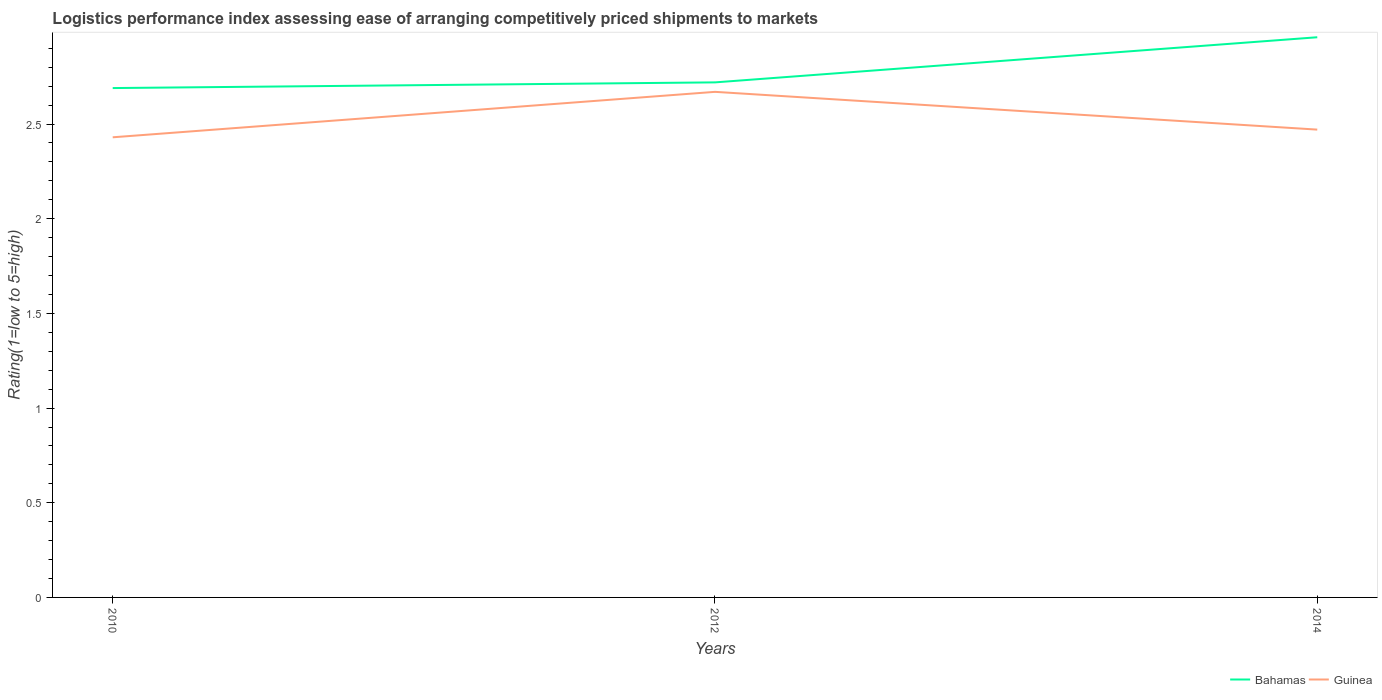How many different coloured lines are there?
Keep it short and to the point. 2. Across all years, what is the maximum Logistic performance index in Guinea?
Keep it short and to the point. 2.43. In which year was the Logistic performance index in Guinea maximum?
Make the answer very short. 2010. What is the total Logistic performance index in Bahamas in the graph?
Give a very brief answer. -0.03. What is the difference between the highest and the second highest Logistic performance index in Bahamas?
Provide a succinct answer. 0.27. What is the difference between the highest and the lowest Logistic performance index in Guinea?
Ensure brevity in your answer.  1. How many lines are there?
Keep it short and to the point. 2. Are the values on the major ticks of Y-axis written in scientific E-notation?
Provide a short and direct response. No. Does the graph contain any zero values?
Ensure brevity in your answer.  No. Where does the legend appear in the graph?
Make the answer very short. Bottom right. How many legend labels are there?
Provide a short and direct response. 2. What is the title of the graph?
Offer a very short reply. Logistics performance index assessing ease of arranging competitively priced shipments to markets. Does "Zambia" appear as one of the legend labels in the graph?
Offer a terse response. No. What is the label or title of the Y-axis?
Offer a terse response. Rating(1=low to 5=high). What is the Rating(1=low to 5=high) of Bahamas in 2010?
Offer a terse response. 2.69. What is the Rating(1=low to 5=high) of Guinea in 2010?
Your answer should be compact. 2.43. What is the Rating(1=low to 5=high) of Bahamas in 2012?
Give a very brief answer. 2.72. What is the Rating(1=low to 5=high) of Guinea in 2012?
Your answer should be compact. 2.67. What is the Rating(1=low to 5=high) in Bahamas in 2014?
Your answer should be very brief. 2.96. What is the Rating(1=low to 5=high) in Guinea in 2014?
Make the answer very short. 2.47. Across all years, what is the maximum Rating(1=low to 5=high) of Bahamas?
Your answer should be very brief. 2.96. Across all years, what is the maximum Rating(1=low to 5=high) of Guinea?
Provide a short and direct response. 2.67. Across all years, what is the minimum Rating(1=low to 5=high) of Bahamas?
Keep it short and to the point. 2.69. Across all years, what is the minimum Rating(1=low to 5=high) in Guinea?
Make the answer very short. 2.43. What is the total Rating(1=low to 5=high) in Bahamas in the graph?
Provide a succinct answer. 8.37. What is the total Rating(1=low to 5=high) of Guinea in the graph?
Offer a terse response. 7.57. What is the difference between the Rating(1=low to 5=high) of Bahamas in 2010 and that in 2012?
Your response must be concise. -0.03. What is the difference between the Rating(1=low to 5=high) in Guinea in 2010 and that in 2012?
Provide a succinct answer. -0.24. What is the difference between the Rating(1=low to 5=high) in Bahamas in 2010 and that in 2014?
Ensure brevity in your answer.  -0.27. What is the difference between the Rating(1=low to 5=high) of Guinea in 2010 and that in 2014?
Give a very brief answer. -0.04. What is the difference between the Rating(1=low to 5=high) in Bahamas in 2012 and that in 2014?
Provide a short and direct response. -0.24. What is the difference between the Rating(1=low to 5=high) in Guinea in 2012 and that in 2014?
Your answer should be compact. 0.2. What is the difference between the Rating(1=low to 5=high) in Bahamas in 2010 and the Rating(1=low to 5=high) in Guinea in 2014?
Ensure brevity in your answer.  0.22. What is the difference between the Rating(1=low to 5=high) in Bahamas in 2012 and the Rating(1=low to 5=high) in Guinea in 2014?
Offer a very short reply. 0.25. What is the average Rating(1=low to 5=high) in Bahamas per year?
Provide a short and direct response. 2.79. What is the average Rating(1=low to 5=high) in Guinea per year?
Your response must be concise. 2.52. In the year 2010, what is the difference between the Rating(1=low to 5=high) in Bahamas and Rating(1=low to 5=high) in Guinea?
Ensure brevity in your answer.  0.26. In the year 2014, what is the difference between the Rating(1=low to 5=high) in Bahamas and Rating(1=low to 5=high) in Guinea?
Provide a short and direct response. 0.49. What is the ratio of the Rating(1=low to 5=high) of Bahamas in 2010 to that in 2012?
Keep it short and to the point. 0.99. What is the ratio of the Rating(1=low to 5=high) of Guinea in 2010 to that in 2012?
Offer a very short reply. 0.91. What is the ratio of the Rating(1=low to 5=high) in Bahamas in 2010 to that in 2014?
Your answer should be compact. 0.91. What is the ratio of the Rating(1=low to 5=high) of Guinea in 2010 to that in 2014?
Offer a terse response. 0.98. What is the ratio of the Rating(1=low to 5=high) in Bahamas in 2012 to that in 2014?
Keep it short and to the point. 0.92. What is the ratio of the Rating(1=low to 5=high) in Guinea in 2012 to that in 2014?
Your answer should be compact. 1.08. What is the difference between the highest and the second highest Rating(1=low to 5=high) in Bahamas?
Ensure brevity in your answer.  0.24. What is the difference between the highest and the second highest Rating(1=low to 5=high) of Guinea?
Provide a short and direct response. 0.2. What is the difference between the highest and the lowest Rating(1=low to 5=high) in Bahamas?
Provide a short and direct response. 0.27. What is the difference between the highest and the lowest Rating(1=low to 5=high) in Guinea?
Offer a very short reply. 0.24. 